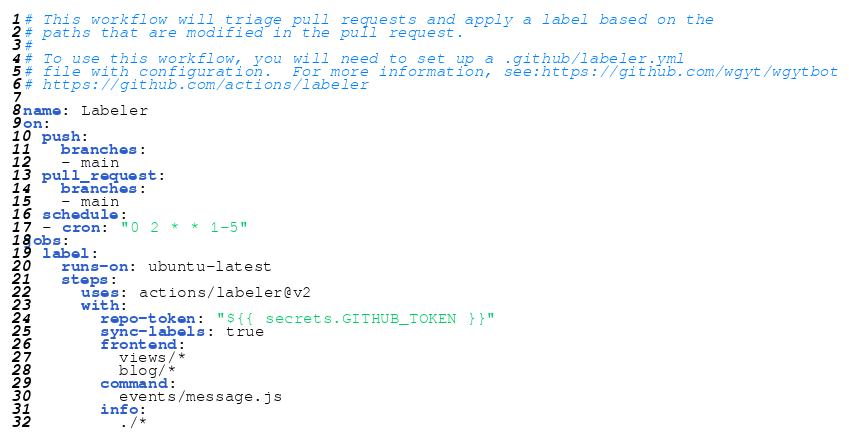Convert code to text. <code><loc_0><loc_0><loc_500><loc_500><_YAML_># This workflow will triage pull requests and apply a label based on the
# paths that are modified in the pull request.
#
# To use this workflow, you will need to set up a .github/labeler.yml
# file with configuration.  For more information, see:https://github.com/wgyt/wgytbot
# https://github.com/actions/labeler

name: Labeler
on:
  push:
    branches:
    - main
  pull_request:
    branches:
    - main
  schedule:
  - cron: "0 2 * * 1-5"
jobs:
  label:
    runs-on: ubuntu-latest
    steps:
      uses: actions/labeler@v2
      with:
        repo-token: "${{ secrets.GITHUB_TOKEN }}"
        sync-labels: true
        frontend:
          views/*
          blog/*
        command:
          events/message.js
        info:
          ./*
</code> 